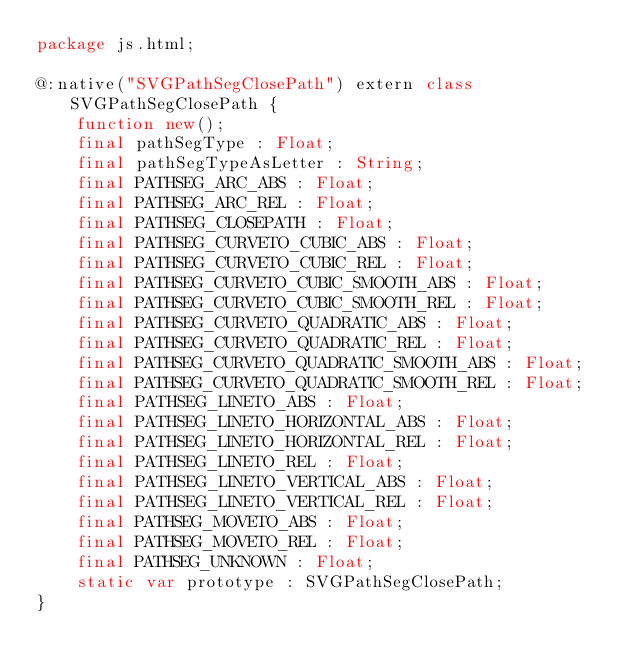Convert code to text. <code><loc_0><loc_0><loc_500><loc_500><_Haxe_>package js.html;

@:native("SVGPathSegClosePath") extern class SVGPathSegClosePath {
	function new();
	final pathSegType : Float;
	final pathSegTypeAsLetter : String;
	final PATHSEG_ARC_ABS : Float;
	final PATHSEG_ARC_REL : Float;
	final PATHSEG_CLOSEPATH : Float;
	final PATHSEG_CURVETO_CUBIC_ABS : Float;
	final PATHSEG_CURVETO_CUBIC_REL : Float;
	final PATHSEG_CURVETO_CUBIC_SMOOTH_ABS : Float;
	final PATHSEG_CURVETO_CUBIC_SMOOTH_REL : Float;
	final PATHSEG_CURVETO_QUADRATIC_ABS : Float;
	final PATHSEG_CURVETO_QUADRATIC_REL : Float;
	final PATHSEG_CURVETO_QUADRATIC_SMOOTH_ABS : Float;
	final PATHSEG_CURVETO_QUADRATIC_SMOOTH_REL : Float;
	final PATHSEG_LINETO_ABS : Float;
	final PATHSEG_LINETO_HORIZONTAL_ABS : Float;
	final PATHSEG_LINETO_HORIZONTAL_REL : Float;
	final PATHSEG_LINETO_REL : Float;
	final PATHSEG_LINETO_VERTICAL_ABS : Float;
	final PATHSEG_LINETO_VERTICAL_REL : Float;
	final PATHSEG_MOVETO_ABS : Float;
	final PATHSEG_MOVETO_REL : Float;
	final PATHSEG_UNKNOWN : Float;
	static var prototype : SVGPathSegClosePath;
}</code> 